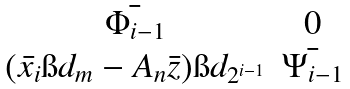<formula> <loc_0><loc_0><loc_500><loc_500>\begin{matrix} \bar { \Phi _ { i - 1 } } & 0 \\ ( \bar { x _ { i } } \i d _ { m } - A _ { n } \bar { z } ) \i d _ { 2 ^ { i - 1 } } & \bar { \Psi _ { i - 1 } } \end{matrix}</formula> 